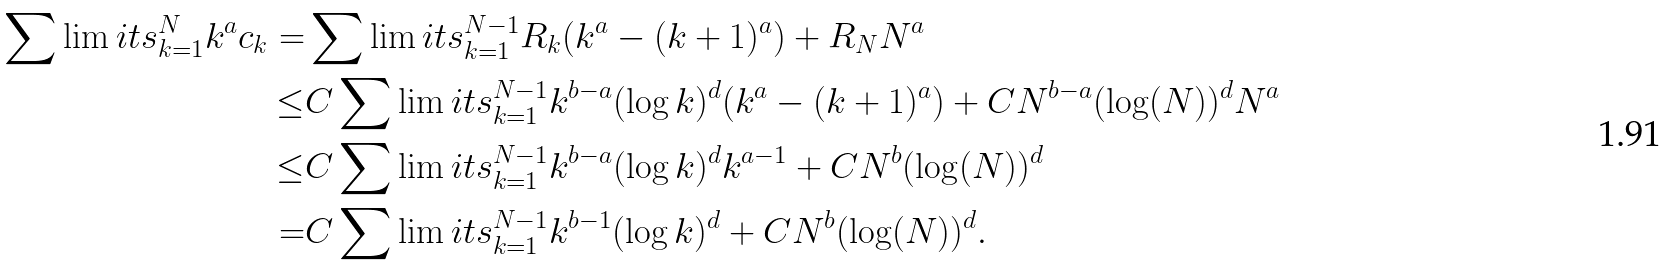Convert formula to latex. <formula><loc_0><loc_0><loc_500><loc_500>\sum \lim i t s _ { k = 1 } ^ { N } k ^ { a } c _ { k } = & \sum \lim i t s _ { k = 1 } ^ { N - 1 } R _ { k } ( k ^ { a } - ( k + 1 ) ^ { a } ) + R _ { N } N ^ { a } \\ \leq & C \sum \lim i t s _ { k = 1 } ^ { N - 1 } k ^ { b - a } ( \log k ) ^ { d } ( k ^ { a } - ( k + 1 ) ^ { a } ) + C N ^ { b - a } ( \log ( N ) ) ^ { d } N ^ { a } \\ \leq & C \sum \lim i t s _ { k = 1 } ^ { N - 1 } k ^ { b - a } ( \log k ) ^ { d } k ^ { a - 1 } + C N ^ { b } ( \log ( N ) ) ^ { d } \\ = & C \sum \lim i t s _ { k = 1 } ^ { N - 1 } k ^ { b - 1 } ( \log k ) ^ { d } + C N ^ { b } ( \log ( N ) ) ^ { d } .</formula> 